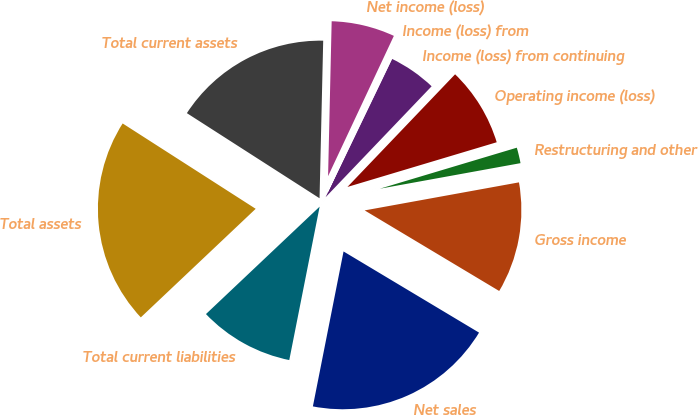Convert chart to OTSL. <chart><loc_0><loc_0><loc_500><loc_500><pie_chart><fcel>Net sales<fcel>Gross income<fcel>Restructuring and other<fcel>Operating income (loss)<fcel>Income (loss) from continuing<fcel>Income (loss) from<fcel>Net income (loss)<fcel>Total current assets<fcel>Total assets<fcel>Total current liabilities<nl><fcel>19.52%<fcel>11.45%<fcel>1.77%<fcel>8.23%<fcel>5.0%<fcel>0.16%<fcel>6.61%<fcel>16.29%<fcel>21.13%<fcel>9.84%<nl></chart> 